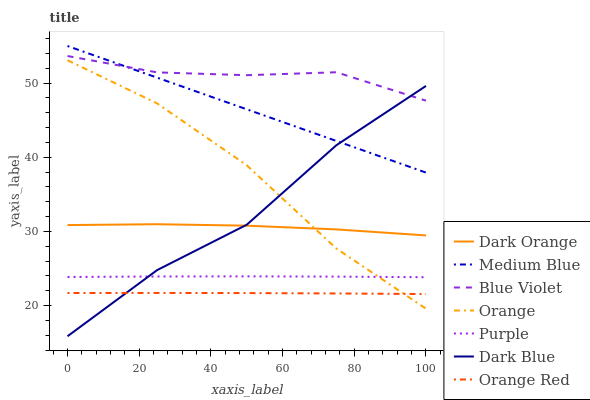Does Orange Red have the minimum area under the curve?
Answer yes or no. Yes. Does Blue Violet have the maximum area under the curve?
Answer yes or no. Yes. Does Purple have the minimum area under the curve?
Answer yes or no. No. Does Purple have the maximum area under the curve?
Answer yes or no. No. Is Medium Blue the smoothest?
Answer yes or no. Yes. Is Dark Blue the roughest?
Answer yes or no. Yes. Is Purple the smoothest?
Answer yes or no. No. Is Purple the roughest?
Answer yes or no. No. Does Dark Blue have the lowest value?
Answer yes or no. Yes. Does Purple have the lowest value?
Answer yes or no. No. Does Medium Blue have the highest value?
Answer yes or no. Yes. Does Purple have the highest value?
Answer yes or no. No. Is Orange Red less than Medium Blue?
Answer yes or no. Yes. Is Dark Orange greater than Purple?
Answer yes or no. Yes. Does Orange intersect Dark Blue?
Answer yes or no. Yes. Is Orange less than Dark Blue?
Answer yes or no. No. Is Orange greater than Dark Blue?
Answer yes or no. No. Does Orange Red intersect Medium Blue?
Answer yes or no. No. 